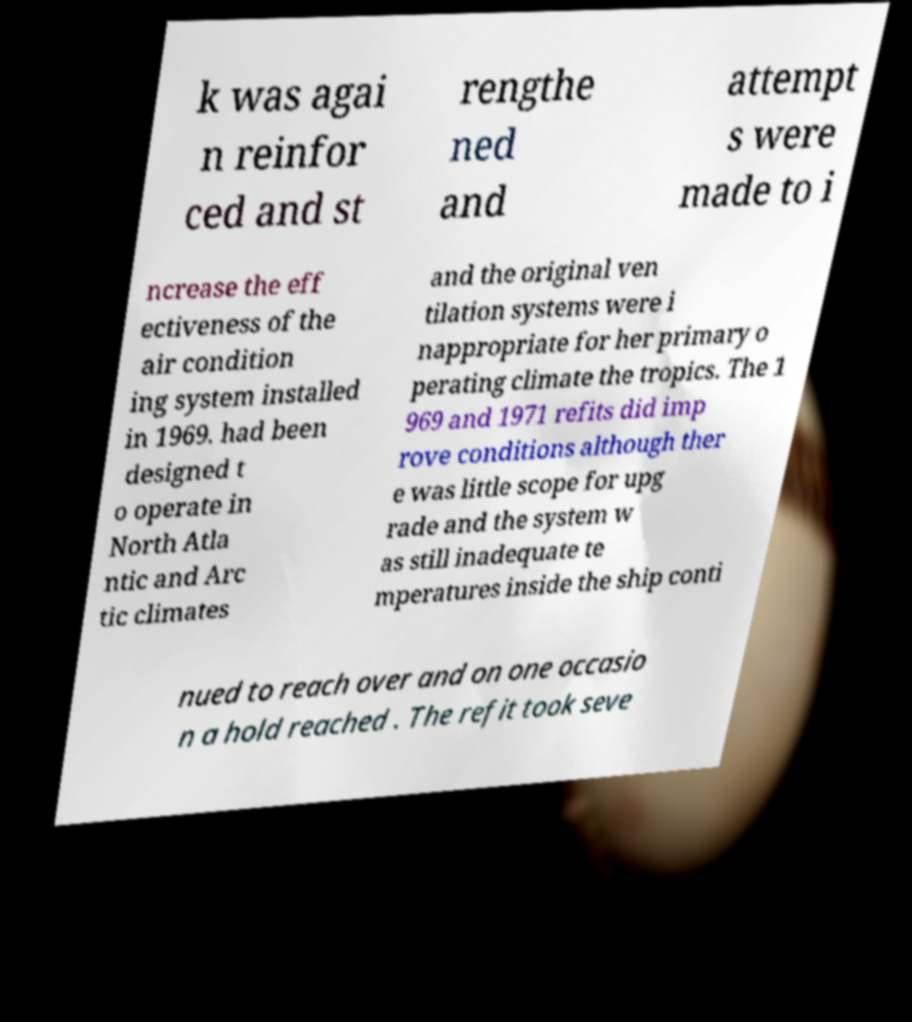I need the written content from this picture converted into text. Can you do that? k was agai n reinfor ced and st rengthe ned and attempt s were made to i ncrease the eff ectiveness of the air condition ing system installed in 1969. had been designed t o operate in North Atla ntic and Arc tic climates and the original ven tilation systems were i nappropriate for her primary o perating climate the tropics. The 1 969 and 1971 refits did imp rove conditions although ther e was little scope for upg rade and the system w as still inadequate te mperatures inside the ship conti nued to reach over and on one occasio n a hold reached . The refit took seve 